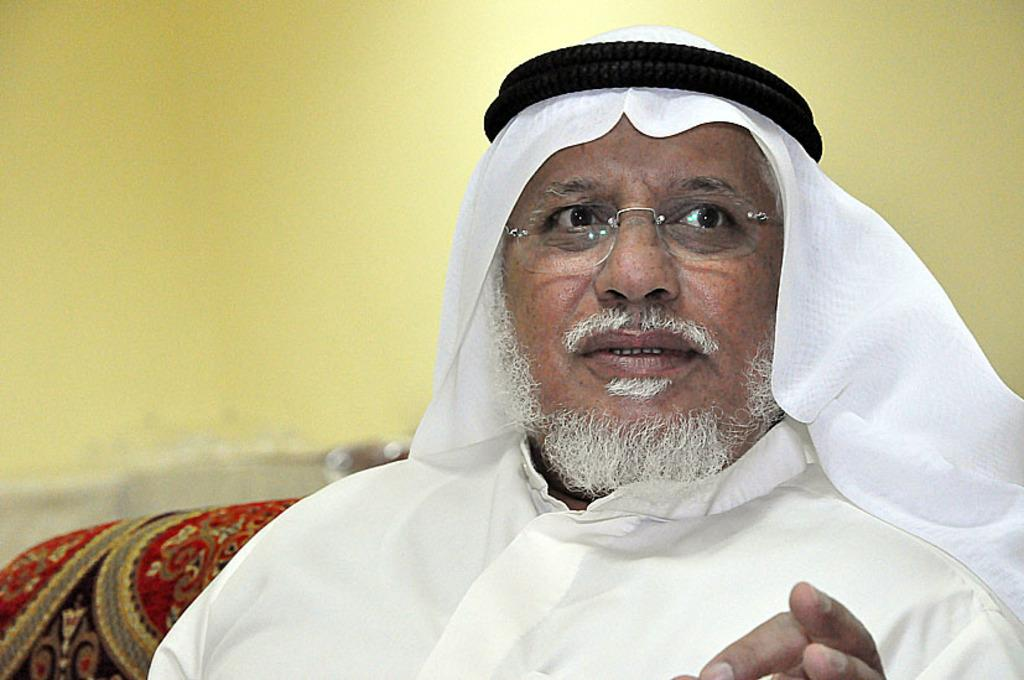What is the main subject in the foreground of the image? There is a person in the foreground of the image. What is the person wearing? The person is wearing a white dress. What is the person doing in the image? The person is sitting on a couch. What can be seen in the background of the image? There is a wall in the background of the image. What type of tail can be seen on the person in the image? There is no tail visible on the person in the image. What kind of beef is being prepared in the background of the image? There is no beef or any indication of food preparation in the image; it features a person sitting on a couch with a wall in the background. 